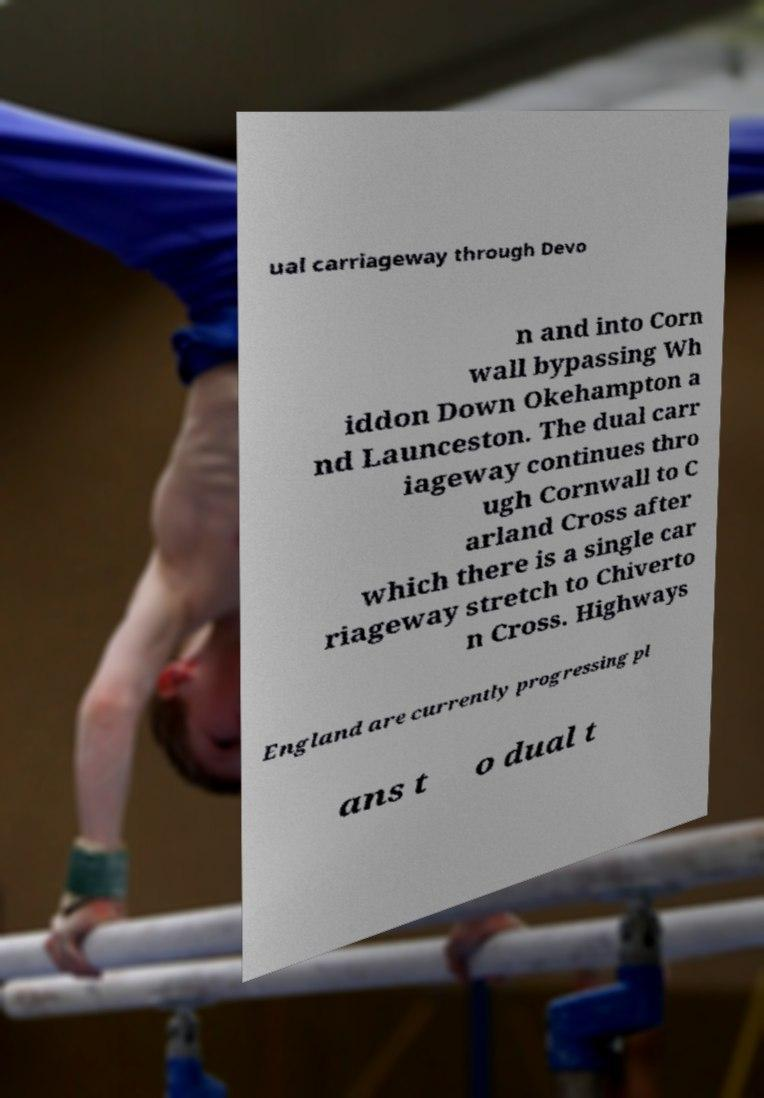Can you read and provide the text displayed in the image?This photo seems to have some interesting text. Can you extract and type it out for me? ual carriageway through Devo n and into Corn wall bypassing Wh iddon Down Okehampton a nd Launceston. The dual carr iageway continues thro ugh Cornwall to C arland Cross after which there is a single car riageway stretch to Chiverto n Cross. Highways England are currently progressing pl ans t o dual t 